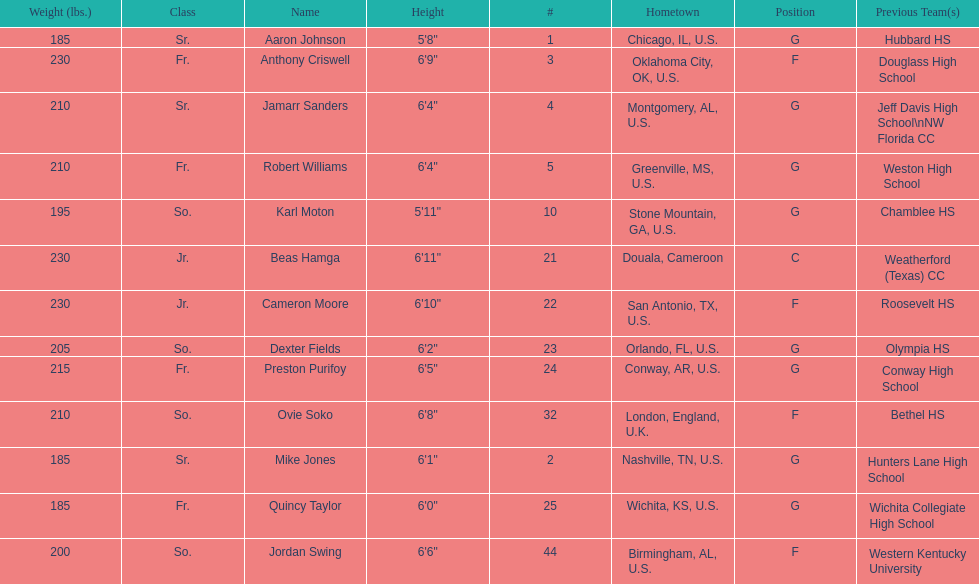Who is first on the roster? Aaron Johnson. 